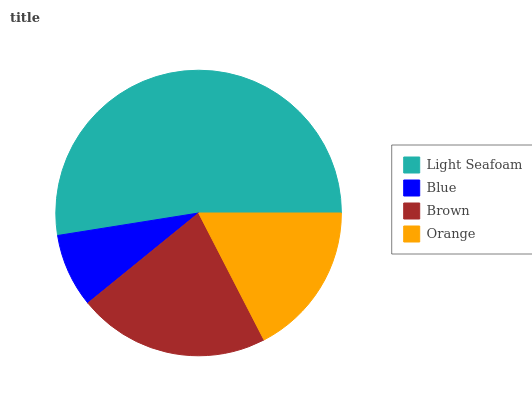Is Blue the minimum?
Answer yes or no. Yes. Is Light Seafoam the maximum?
Answer yes or no. Yes. Is Brown the minimum?
Answer yes or no. No. Is Brown the maximum?
Answer yes or no. No. Is Brown greater than Blue?
Answer yes or no. Yes. Is Blue less than Brown?
Answer yes or no. Yes. Is Blue greater than Brown?
Answer yes or no. No. Is Brown less than Blue?
Answer yes or no. No. Is Brown the high median?
Answer yes or no. Yes. Is Orange the low median?
Answer yes or no. Yes. Is Orange the high median?
Answer yes or no. No. Is Light Seafoam the low median?
Answer yes or no. No. 